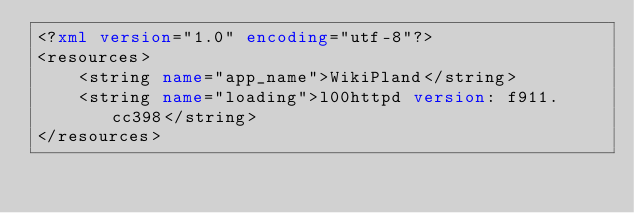<code> <loc_0><loc_0><loc_500><loc_500><_XML_><?xml version="1.0" encoding="utf-8"?>
<resources>
    <string name="app_name">WikiPland</string>
    <string name="loading">l00httpd version: f911.cc398</string>
</resources>
</code> 